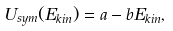Convert formula to latex. <formula><loc_0><loc_0><loc_500><loc_500>U _ { s y m } ( E _ { k i n } ) = a - b E _ { k i n } ,</formula> 